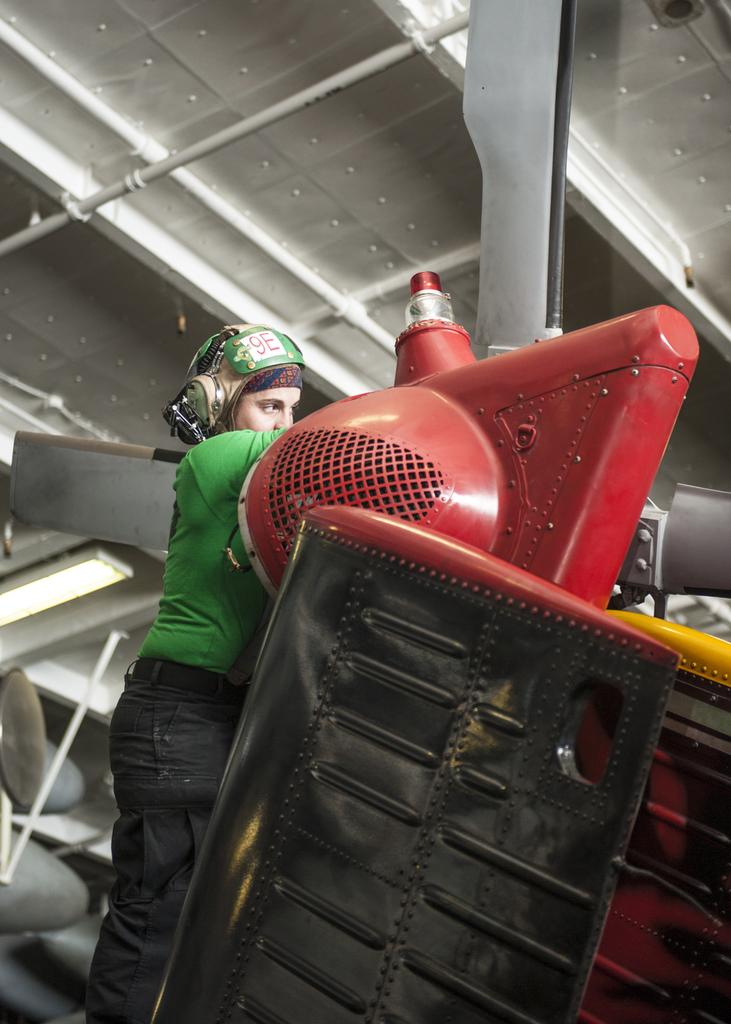Who or what is present in the image? There is a person in the image. What is the person wearing? The person is wearing a helmet. What can be seen in front of the person? There is machinery and metal rods in front of the person. What type of square is being discovered by the person in the image? There is no square or discovery mentioned in the image; it only shows a person wearing a helmet with machinery and metal rods in front of them. 